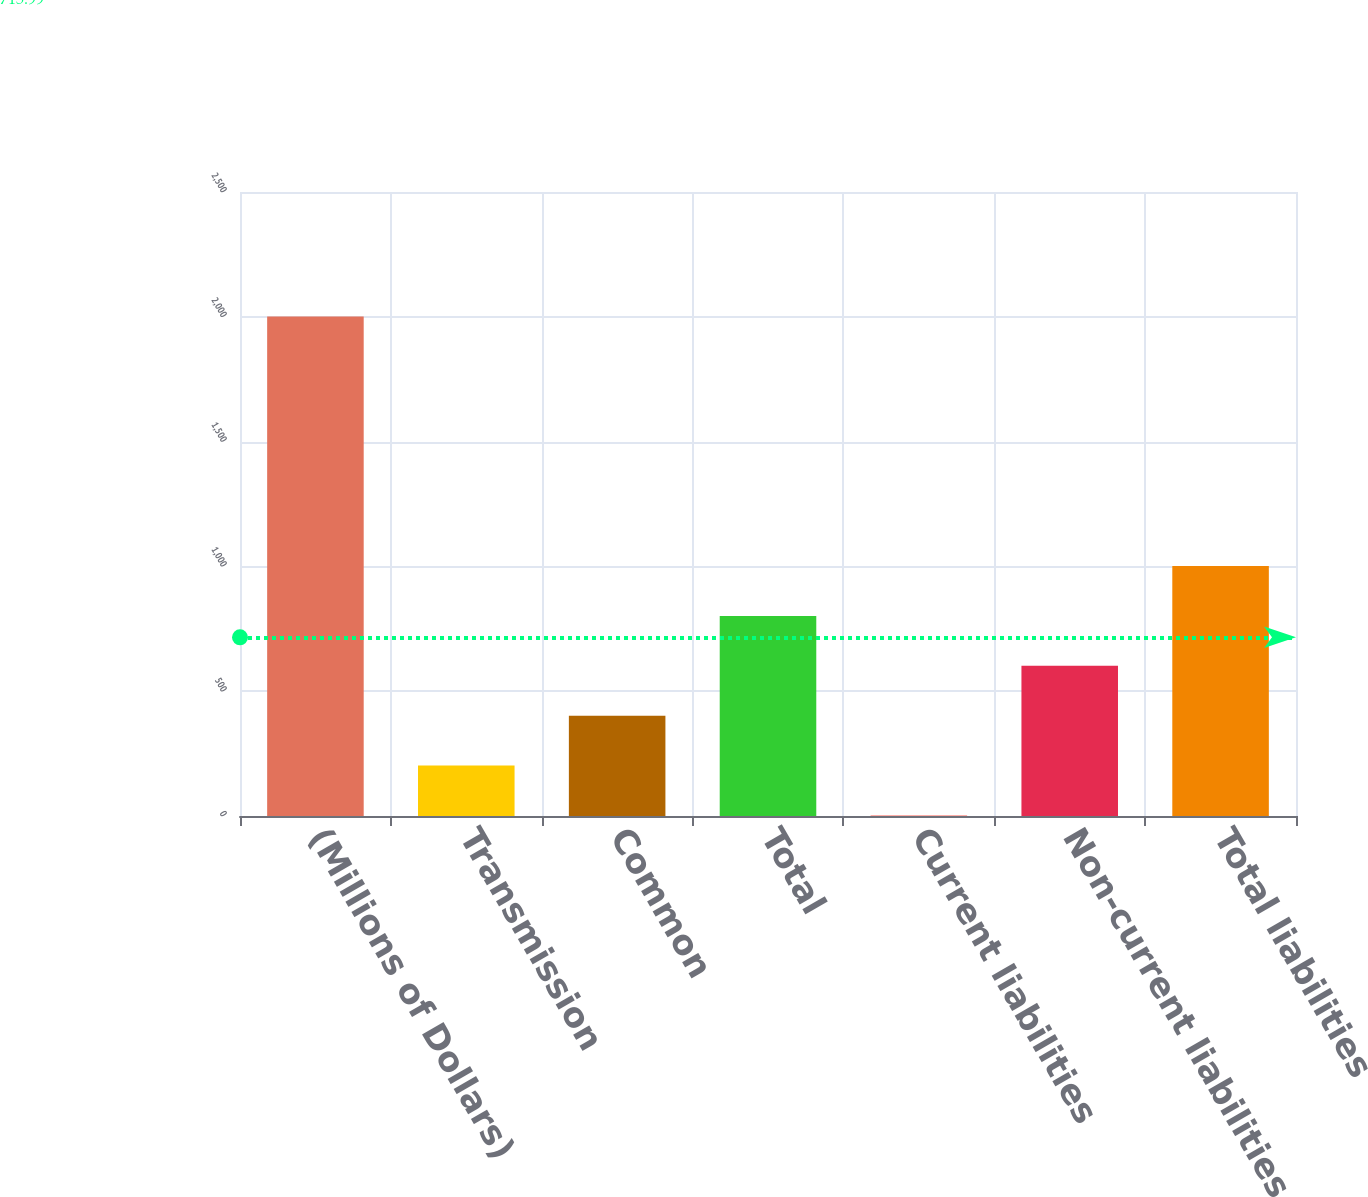Convert chart to OTSL. <chart><loc_0><loc_0><loc_500><loc_500><bar_chart><fcel>(Millions of Dollars)<fcel>Transmission<fcel>Common<fcel>Total<fcel>Current liabilities<fcel>Non-current liabilities<fcel>Total liabilities<nl><fcel>2001<fcel>201.99<fcel>401.88<fcel>801.66<fcel>2.1<fcel>601.77<fcel>1001.55<nl></chart> 